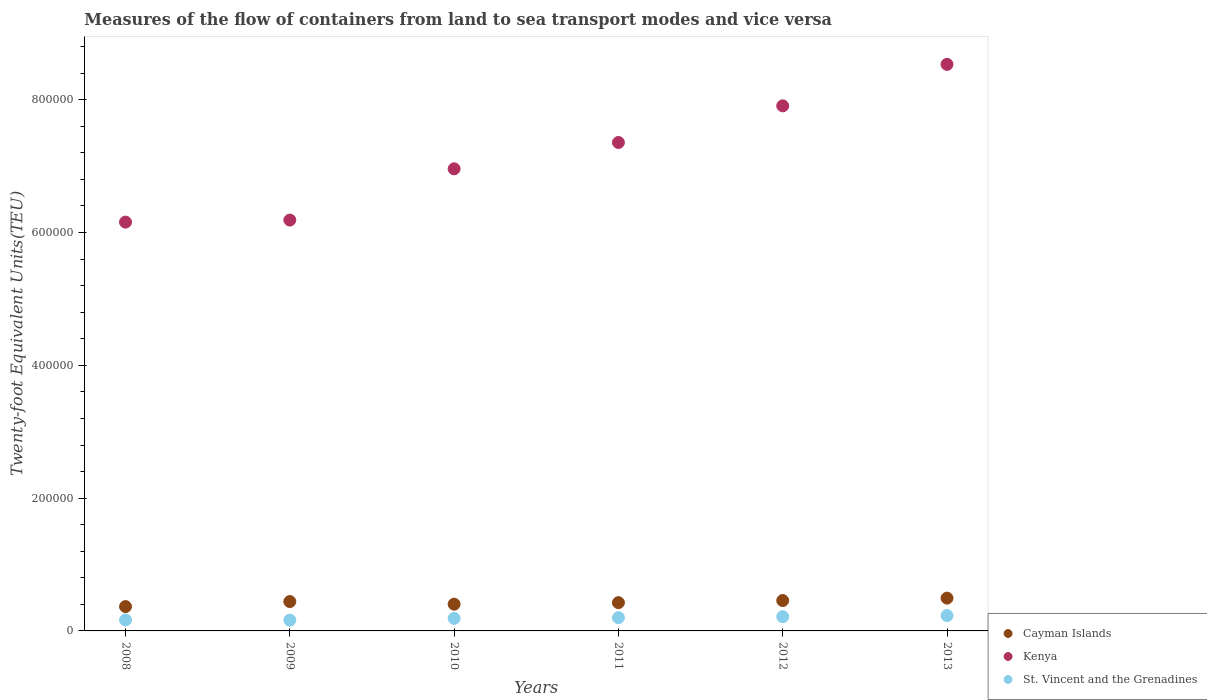What is the container port traffic in St. Vincent and the Grenadines in 2008?
Your answer should be very brief. 1.66e+04. Across all years, what is the maximum container port traffic in Kenya?
Offer a very short reply. 8.53e+05. Across all years, what is the minimum container port traffic in Kenya?
Ensure brevity in your answer.  6.16e+05. In which year was the container port traffic in Kenya maximum?
Your response must be concise. 2013. What is the total container port traffic in Cayman Islands in the graph?
Offer a very short reply. 2.59e+05. What is the difference between the container port traffic in St. Vincent and the Grenadines in 2009 and that in 2012?
Provide a succinct answer. -5183.42. What is the difference between the container port traffic in St. Vincent and the Grenadines in 2009 and the container port traffic in Cayman Islands in 2012?
Your answer should be compact. -2.95e+04. What is the average container port traffic in Cayman Islands per year?
Offer a terse response. 4.31e+04. In the year 2009, what is the difference between the container port traffic in St. Vincent and the Grenadines and container port traffic in Kenya?
Your response must be concise. -6.03e+05. What is the ratio of the container port traffic in St. Vincent and the Grenadines in 2010 to that in 2012?
Your answer should be very brief. 0.88. Is the container port traffic in St. Vincent and the Grenadines in 2009 less than that in 2013?
Your answer should be very brief. Yes. Is the difference between the container port traffic in St. Vincent and the Grenadines in 2009 and 2011 greater than the difference between the container port traffic in Kenya in 2009 and 2011?
Offer a very short reply. Yes. What is the difference between the highest and the second highest container port traffic in St. Vincent and the Grenadines?
Offer a terse response. 1692.29. What is the difference between the highest and the lowest container port traffic in Cayman Islands?
Your answer should be very brief. 1.27e+04. In how many years, is the container port traffic in St. Vincent and the Grenadines greater than the average container port traffic in St. Vincent and the Grenadines taken over all years?
Provide a short and direct response. 3. Does the container port traffic in Kenya monotonically increase over the years?
Give a very brief answer. Yes. Is the container port traffic in Cayman Islands strictly less than the container port traffic in St. Vincent and the Grenadines over the years?
Provide a short and direct response. No. Does the graph contain any zero values?
Your response must be concise. No. Does the graph contain grids?
Offer a very short reply. No. Where does the legend appear in the graph?
Offer a terse response. Bottom right. What is the title of the graph?
Offer a very short reply. Measures of the flow of containers from land to sea transport modes and vice versa. What is the label or title of the X-axis?
Your answer should be very brief. Years. What is the label or title of the Y-axis?
Ensure brevity in your answer.  Twenty-foot Equivalent Units(TEU). What is the Twenty-foot Equivalent Units(TEU) of Cayman Islands in 2008?
Keep it short and to the point. 3.66e+04. What is the Twenty-foot Equivalent Units(TEU) in Kenya in 2008?
Keep it short and to the point. 6.16e+05. What is the Twenty-foot Equivalent Units(TEU) in St. Vincent and the Grenadines in 2008?
Keep it short and to the point. 1.66e+04. What is the Twenty-foot Equivalent Units(TEU) of Cayman Islands in 2009?
Your answer should be compact. 4.42e+04. What is the Twenty-foot Equivalent Units(TEU) of Kenya in 2009?
Keep it short and to the point. 6.19e+05. What is the Twenty-foot Equivalent Units(TEU) of St. Vincent and the Grenadines in 2009?
Your answer should be compact. 1.62e+04. What is the Twenty-foot Equivalent Units(TEU) of Cayman Islands in 2010?
Give a very brief answer. 4.03e+04. What is the Twenty-foot Equivalent Units(TEU) of Kenya in 2010?
Offer a very short reply. 6.96e+05. What is the Twenty-foot Equivalent Units(TEU) of St. Vincent and the Grenadines in 2010?
Keep it short and to the point. 1.89e+04. What is the Twenty-foot Equivalent Units(TEU) of Cayman Islands in 2011?
Ensure brevity in your answer.  4.26e+04. What is the Twenty-foot Equivalent Units(TEU) in Kenya in 2011?
Your answer should be compact. 7.36e+05. What is the Twenty-foot Equivalent Units(TEU) of St. Vincent and the Grenadines in 2011?
Give a very brief answer. 1.99e+04. What is the Twenty-foot Equivalent Units(TEU) in Cayman Islands in 2012?
Ensure brevity in your answer.  4.58e+04. What is the Twenty-foot Equivalent Units(TEU) of Kenya in 2012?
Make the answer very short. 7.91e+05. What is the Twenty-foot Equivalent Units(TEU) in St. Vincent and the Grenadines in 2012?
Make the answer very short. 2.14e+04. What is the Twenty-foot Equivalent Units(TEU) of Cayman Islands in 2013?
Your answer should be very brief. 4.94e+04. What is the Twenty-foot Equivalent Units(TEU) of Kenya in 2013?
Your response must be concise. 8.53e+05. What is the Twenty-foot Equivalent Units(TEU) in St. Vincent and the Grenadines in 2013?
Provide a short and direct response. 2.31e+04. Across all years, what is the maximum Twenty-foot Equivalent Units(TEU) of Cayman Islands?
Your response must be concise. 4.94e+04. Across all years, what is the maximum Twenty-foot Equivalent Units(TEU) of Kenya?
Provide a succinct answer. 8.53e+05. Across all years, what is the maximum Twenty-foot Equivalent Units(TEU) of St. Vincent and the Grenadines?
Give a very brief answer. 2.31e+04. Across all years, what is the minimum Twenty-foot Equivalent Units(TEU) of Cayman Islands?
Make the answer very short. 3.66e+04. Across all years, what is the minimum Twenty-foot Equivalent Units(TEU) in Kenya?
Your answer should be compact. 6.16e+05. Across all years, what is the minimum Twenty-foot Equivalent Units(TEU) of St. Vincent and the Grenadines?
Give a very brief answer. 1.62e+04. What is the total Twenty-foot Equivalent Units(TEU) of Cayman Islands in the graph?
Your answer should be very brief. 2.59e+05. What is the total Twenty-foot Equivalent Units(TEU) in Kenya in the graph?
Offer a very short reply. 4.31e+06. What is the total Twenty-foot Equivalent Units(TEU) in St. Vincent and the Grenadines in the graph?
Ensure brevity in your answer.  1.16e+05. What is the difference between the Twenty-foot Equivalent Units(TEU) of Cayman Islands in 2008 and that in 2009?
Make the answer very short. -7571. What is the difference between the Twenty-foot Equivalent Units(TEU) of Kenya in 2008 and that in 2009?
Make the answer very short. -3083. What is the difference between the Twenty-foot Equivalent Units(TEU) in St. Vincent and the Grenadines in 2008 and that in 2009?
Your answer should be very brief. 332. What is the difference between the Twenty-foot Equivalent Units(TEU) in Cayman Islands in 2008 and that in 2010?
Make the answer very short. -3637. What is the difference between the Twenty-foot Equivalent Units(TEU) of Kenya in 2008 and that in 2010?
Provide a succinct answer. -8.03e+04. What is the difference between the Twenty-foot Equivalent Units(TEU) of St. Vincent and the Grenadines in 2008 and that in 2010?
Keep it short and to the point. -2282.32. What is the difference between the Twenty-foot Equivalent Units(TEU) of Cayman Islands in 2008 and that in 2011?
Keep it short and to the point. -5933. What is the difference between the Twenty-foot Equivalent Units(TEU) in Kenya in 2008 and that in 2011?
Make the answer very short. -1.20e+05. What is the difference between the Twenty-foot Equivalent Units(TEU) in St. Vincent and the Grenadines in 2008 and that in 2011?
Keep it short and to the point. -3356.9. What is the difference between the Twenty-foot Equivalent Units(TEU) of Cayman Islands in 2008 and that in 2012?
Keep it short and to the point. -9126.27. What is the difference between the Twenty-foot Equivalent Units(TEU) of Kenya in 2008 and that in 2012?
Make the answer very short. -1.75e+05. What is the difference between the Twenty-foot Equivalent Units(TEU) of St. Vincent and the Grenadines in 2008 and that in 2012?
Provide a short and direct response. -4851.42. What is the difference between the Twenty-foot Equivalent Units(TEU) in Cayman Islands in 2008 and that in 2013?
Give a very brief answer. -1.27e+04. What is the difference between the Twenty-foot Equivalent Units(TEU) of Kenya in 2008 and that in 2013?
Offer a terse response. -2.38e+05. What is the difference between the Twenty-foot Equivalent Units(TEU) in St. Vincent and the Grenadines in 2008 and that in 2013?
Provide a succinct answer. -6543.71. What is the difference between the Twenty-foot Equivalent Units(TEU) in Cayman Islands in 2009 and that in 2010?
Give a very brief answer. 3934. What is the difference between the Twenty-foot Equivalent Units(TEU) of Kenya in 2009 and that in 2010?
Keep it short and to the point. -7.72e+04. What is the difference between the Twenty-foot Equivalent Units(TEU) in St. Vincent and the Grenadines in 2009 and that in 2010?
Make the answer very short. -2614.32. What is the difference between the Twenty-foot Equivalent Units(TEU) of Cayman Islands in 2009 and that in 2011?
Ensure brevity in your answer.  1638. What is the difference between the Twenty-foot Equivalent Units(TEU) of Kenya in 2009 and that in 2011?
Offer a terse response. -1.17e+05. What is the difference between the Twenty-foot Equivalent Units(TEU) of St. Vincent and the Grenadines in 2009 and that in 2011?
Provide a short and direct response. -3688.9. What is the difference between the Twenty-foot Equivalent Units(TEU) in Cayman Islands in 2009 and that in 2012?
Provide a short and direct response. -1555.28. What is the difference between the Twenty-foot Equivalent Units(TEU) of Kenya in 2009 and that in 2012?
Give a very brief answer. -1.72e+05. What is the difference between the Twenty-foot Equivalent Units(TEU) in St. Vincent and the Grenadines in 2009 and that in 2012?
Make the answer very short. -5183.42. What is the difference between the Twenty-foot Equivalent Units(TEU) in Cayman Islands in 2009 and that in 2013?
Make the answer very short. -5171.13. What is the difference between the Twenty-foot Equivalent Units(TEU) of Kenya in 2009 and that in 2013?
Ensure brevity in your answer.  -2.35e+05. What is the difference between the Twenty-foot Equivalent Units(TEU) of St. Vincent and the Grenadines in 2009 and that in 2013?
Offer a very short reply. -6875.71. What is the difference between the Twenty-foot Equivalent Units(TEU) in Cayman Islands in 2010 and that in 2011?
Your answer should be compact. -2296. What is the difference between the Twenty-foot Equivalent Units(TEU) in Kenya in 2010 and that in 2011?
Your response must be concise. -3.97e+04. What is the difference between the Twenty-foot Equivalent Units(TEU) of St. Vincent and the Grenadines in 2010 and that in 2011?
Your response must be concise. -1074.58. What is the difference between the Twenty-foot Equivalent Units(TEU) of Cayman Islands in 2010 and that in 2012?
Provide a succinct answer. -5489.27. What is the difference between the Twenty-foot Equivalent Units(TEU) in Kenya in 2010 and that in 2012?
Your answer should be very brief. -9.48e+04. What is the difference between the Twenty-foot Equivalent Units(TEU) in St. Vincent and the Grenadines in 2010 and that in 2012?
Ensure brevity in your answer.  -2569.1. What is the difference between the Twenty-foot Equivalent Units(TEU) of Cayman Islands in 2010 and that in 2013?
Your answer should be very brief. -9105.13. What is the difference between the Twenty-foot Equivalent Units(TEU) in Kenya in 2010 and that in 2013?
Provide a succinct answer. -1.57e+05. What is the difference between the Twenty-foot Equivalent Units(TEU) of St. Vincent and the Grenadines in 2010 and that in 2013?
Offer a terse response. -4261.39. What is the difference between the Twenty-foot Equivalent Units(TEU) in Cayman Islands in 2011 and that in 2012?
Keep it short and to the point. -3193.28. What is the difference between the Twenty-foot Equivalent Units(TEU) in Kenya in 2011 and that in 2012?
Keep it short and to the point. -5.52e+04. What is the difference between the Twenty-foot Equivalent Units(TEU) in St. Vincent and the Grenadines in 2011 and that in 2012?
Your answer should be compact. -1494.52. What is the difference between the Twenty-foot Equivalent Units(TEU) in Cayman Islands in 2011 and that in 2013?
Provide a short and direct response. -6809.13. What is the difference between the Twenty-foot Equivalent Units(TEU) of Kenya in 2011 and that in 2013?
Keep it short and to the point. -1.18e+05. What is the difference between the Twenty-foot Equivalent Units(TEU) of St. Vincent and the Grenadines in 2011 and that in 2013?
Make the answer very short. -3186.81. What is the difference between the Twenty-foot Equivalent Units(TEU) of Cayman Islands in 2012 and that in 2013?
Your response must be concise. -3615.85. What is the difference between the Twenty-foot Equivalent Units(TEU) of Kenya in 2012 and that in 2013?
Keep it short and to the point. -6.25e+04. What is the difference between the Twenty-foot Equivalent Units(TEU) in St. Vincent and the Grenadines in 2012 and that in 2013?
Your answer should be compact. -1692.29. What is the difference between the Twenty-foot Equivalent Units(TEU) in Cayman Islands in 2008 and the Twenty-foot Equivalent Units(TEU) in Kenya in 2009?
Offer a terse response. -5.82e+05. What is the difference between the Twenty-foot Equivalent Units(TEU) in Cayman Islands in 2008 and the Twenty-foot Equivalent Units(TEU) in St. Vincent and the Grenadines in 2009?
Keep it short and to the point. 2.04e+04. What is the difference between the Twenty-foot Equivalent Units(TEU) in Kenya in 2008 and the Twenty-foot Equivalent Units(TEU) in St. Vincent and the Grenadines in 2009?
Your response must be concise. 5.99e+05. What is the difference between the Twenty-foot Equivalent Units(TEU) of Cayman Islands in 2008 and the Twenty-foot Equivalent Units(TEU) of Kenya in 2010?
Your answer should be compact. -6.59e+05. What is the difference between the Twenty-foot Equivalent Units(TEU) of Cayman Islands in 2008 and the Twenty-foot Equivalent Units(TEU) of St. Vincent and the Grenadines in 2010?
Your answer should be compact. 1.78e+04. What is the difference between the Twenty-foot Equivalent Units(TEU) of Kenya in 2008 and the Twenty-foot Equivalent Units(TEU) of St. Vincent and the Grenadines in 2010?
Offer a terse response. 5.97e+05. What is the difference between the Twenty-foot Equivalent Units(TEU) of Cayman Islands in 2008 and the Twenty-foot Equivalent Units(TEU) of Kenya in 2011?
Provide a succinct answer. -6.99e+05. What is the difference between the Twenty-foot Equivalent Units(TEU) of Cayman Islands in 2008 and the Twenty-foot Equivalent Units(TEU) of St. Vincent and the Grenadines in 2011?
Make the answer very short. 1.67e+04. What is the difference between the Twenty-foot Equivalent Units(TEU) of Kenya in 2008 and the Twenty-foot Equivalent Units(TEU) of St. Vincent and the Grenadines in 2011?
Your answer should be compact. 5.96e+05. What is the difference between the Twenty-foot Equivalent Units(TEU) of Cayman Islands in 2008 and the Twenty-foot Equivalent Units(TEU) of Kenya in 2012?
Keep it short and to the point. -7.54e+05. What is the difference between the Twenty-foot Equivalent Units(TEU) in Cayman Islands in 2008 and the Twenty-foot Equivalent Units(TEU) in St. Vincent and the Grenadines in 2012?
Provide a short and direct response. 1.52e+04. What is the difference between the Twenty-foot Equivalent Units(TEU) of Kenya in 2008 and the Twenty-foot Equivalent Units(TEU) of St. Vincent and the Grenadines in 2012?
Give a very brief answer. 5.94e+05. What is the difference between the Twenty-foot Equivalent Units(TEU) of Cayman Islands in 2008 and the Twenty-foot Equivalent Units(TEU) of Kenya in 2013?
Offer a very short reply. -8.17e+05. What is the difference between the Twenty-foot Equivalent Units(TEU) in Cayman Islands in 2008 and the Twenty-foot Equivalent Units(TEU) in St. Vincent and the Grenadines in 2013?
Make the answer very short. 1.35e+04. What is the difference between the Twenty-foot Equivalent Units(TEU) in Kenya in 2008 and the Twenty-foot Equivalent Units(TEU) in St. Vincent and the Grenadines in 2013?
Provide a succinct answer. 5.93e+05. What is the difference between the Twenty-foot Equivalent Units(TEU) of Cayman Islands in 2009 and the Twenty-foot Equivalent Units(TEU) of Kenya in 2010?
Your response must be concise. -6.52e+05. What is the difference between the Twenty-foot Equivalent Units(TEU) in Cayman Islands in 2009 and the Twenty-foot Equivalent Units(TEU) in St. Vincent and the Grenadines in 2010?
Provide a short and direct response. 2.54e+04. What is the difference between the Twenty-foot Equivalent Units(TEU) in Kenya in 2009 and the Twenty-foot Equivalent Units(TEU) in St. Vincent and the Grenadines in 2010?
Offer a terse response. 6.00e+05. What is the difference between the Twenty-foot Equivalent Units(TEU) of Cayman Islands in 2009 and the Twenty-foot Equivalent Units(TEU) of Kenya in 2011?
Your answer should be compact. -6.91e+05. What is the difference between the Twenty-foot Equivalent Units(TEU) of Cayman Islands in 2009 and the Twenty-foot Equivalent Units(TEU) of St. Vincent and the Grenadines in 2011?
Offer a terse response. 2.43e+04. What is the difference between the Twenty-foot Equivalent Units(TEU) of Kenya in 2009 and the Twenty-foot Equivalent Units(TEU) of St. Vincent and the Grenadines in 2011?
Keep it short and to the point. 5.99e+05. What is the difference between the Twenty-foot Equivalent Units(TEU) in Cayman Islands in 2009 and the Twenty-foot Equivalent Units(TEU) in Kenya in 2012?
Ensure brevity in your answer.  -7.47e+05. What is the difference between the Twenty-foot Equivalent Units(TEU) of Cayman Islands in 2009 and the Twenty-foot Equivalent Units(TEU) of St. Vincent and the Grenadines in 2012?
Provide a succinct answer. 2.28e+04. What is the difference between the Twenty-foot Equivalent Units(TEU) of Kenya in 2009 and the Twenty-foot Equivalent Units(TEU) of St. Vincent and the Grenadines in 2012?
Provide a short and direct response. 5.97e+05. What is the difference between the Twenty-foot Equivalent Units(TEU) of Cayman Islands in 2009 and the Twenty-foot Equivalent Units(TEU) of Kenya in 2013?
Provide a short and direct response. -8.09e+05. What is the difference between the Twenty-foot Equivalent Units(TEU) in Cayman Islands in 2009 and the Twenty-foot Equivalent Units(TEU) in St. Vincent and the Grenadines in 2013?
Your answer should be compact. 2.11e+04. What is the difference between the Twenty-foot Equivalent Units(TEU) in Kenya in 2009 and the Twenty-foot Equivalent Units(TEU) in St. Vincent and the Grenadines in 2013?
Your answer should be very brief. 5.96e+05. What is the difference between the Twenty-foot Equivalent Units(TEU) of Cayman Islands in 2010 and the Twenty-foot Equivalent Units(TEU) of Kenya in 2011?
Make the answer very short. -6.95e+05. What is the difference between the Twenty-foot Equivalent Units(TEU) of Cayman Islands in 2010 and the Twenty-foot Equivalent Units(TEU) of St. Vincent and the Grenadines in 2011?
Make the answer very short. 2.04e+04. What is the difference between the Twenty-foot Equivalent Units(TEU) in Kenya in 2010 and the Twenty-foot Equivalent Units(TEU) in St. Vincent and the Grenadines in 2011?
Keep it short and to the point. 6.76e+05. What is the difference between the Twenty-foot Equivalent Units(TEU) in Cayman Islands in 2010 and the Twenty-foot Equivalent Units(TEU) in Kenya in 2012?
Your answer should be very brief. -7.51e+05. What is the difference between the Twenty-foot Equivalent Units(TEU) in Cayman Islands in 2010 and the Twenty-foot Equivalent Units(TEU) in St. Vincent and the Grenadines in 2012?
Your answer should be compact. 1.89e+04. What is the difference between the Twenty-foot Equivalent Units(TEU) in Kenya in 2010 and the Twenty-foot Equivalent Units(TEU) in St. Vincent and the Grenadines in 2012?
Provide a short and direct response. 6.75e+05. What is the difference between the Twenty-foot Equivalent Units(TEU) in Cayman Islands in 2010 and the Twenty-foot Equivalent Units(TEU) in Kenya in 2013?
Provide a short and direct response. -8.13e+05. What is the difference between the Twenty-foot Equivalent Units(TEU) in Cayman Islands in 2010 and the Twenty-foot Equivalent Units(TEU) in St. Vincent and the Grenadines in 2013?
Offer a terse response. 1.72e+04. What is the difference between the Twenty-foot Equivalent Units(TEU) in Kenya in 2010 and the Twenty-foot Equivalent Units(TEU) in St. Vincent and the Grenadines in 2013?
Provide a succinct answer. 6.73e+05. What is the difference between the Twenty-foot Equivalent Units(TEU) of Cayman Islands in 2011 and the Twenty-foot Equivalent Units(TEU) of Kenya in 2012?
Make the answer very short. -7.48e+05. What is the difference between the Twenty-foot Equivalent Units(TEU) in Cayman Islands in 2011 and the Twenty-foot Equivalent Units(TEU) in St. Vincent and the Grenadines in 2012?
Provide a short and direct response. 2.12e+04. What is the difference between the Twenty-foot Equivalent Units(TEU) in Kenya in 2011 and the Twenty-foot Equivalent Units(TEU) in St. Vincent and the Grenadines in 2012?
Your answer should be compact. 7.14e+05. What is the difference between the Twenty-foot Equivalent Units(TEU) of Cayman Islands in 2011 and the Twenty-foot Equivalent Units(TEU) of Kenya in 2013?
Offer a very short reply. -8.11e+05. What is the difference between the Twenty-foot Equivalent Units(TEU) of Cayman Islands in 2011 and the Twenty-foot Equivalent Units(TEU) of St. Vincent and the Grenadines in 2013?
Ensure brevity in your answer.  1.95e+04. What is the difference between the Twenty-foot Equivalent Units(TEU) in Kenya in 2011 and the Twenty-foot Equivalent Units(TEU) in St. Vincent and the Grenadines in 2013?
Offer a terse response. 7.13e+05. What is the difference between the Twenty-foot Equivalent Units(TEU) of Cayman Islands in 2012 and the Twenty-foot Equivalent Units(TEU) of Kenya in 2013?
Provide a short and direct response. -8.08e+05. What is the difference between the Twenty-foot Equivalent Units(TEU) in Cayman Islands in 2012 and the Twenty-foot Equivalent Units(TEU) in St. Vincent and the Grenadines in 2013?
Keep it short and to the point. 2.27e+04. What is the difference between the Twenty-foot Equivalent Units(TEU) of Kenya in 2012 and the Twenty-foot Equivalent Units(TEU) of St. Vincent and the Grenadines in 2013?
Your response must be concise. 7.68e+05. What is the average Twenty-foot Equivalent Units(TEU) of Cayman Islands per year?
Offer a very short reply. 4.31e+04. What is the average Twenty-foot Equivalent Units(TEU) in Kenya per year?
Make the answer very short. 7.18e+05. What is the average Twenty-foot Equivalent Units(TEU) in St. Vincent and the Grenadines per year?
Your response must be concise. 1.94e+04. In the year 2008, what is the difference between the Twenty-foot Equivalent Units(TEU) of Cayman Islands and Twenty-foot Equivalent Units(TEU) of Kenya?
Offer a very short reply. -5.79e+05. In the year 2008, what is the difference between the Twenty-foot Equivalent Units(TEU) of Cayman Islands and Twenty-foot Equivalent Units(TEU) of St. Vincent and the Grenadines?
Give a very brief answer. 2.01e+04. In the year 2008, what is the difference between the Twenty-foot Equivalent Units(TEU) in Kenya and Twenty-foot Equivalent Units(TEU) in St. Vincent and the Grenadines?
Make the answer very short. 5.99e+05. In the year 2009, what is the difference between the Twenty-foot Equivalent Units(TEU) of Cayman Islands and Twenty-foot Equivalent Units(TEU) of Kenya?
Provide a succinct answer. -5.75e+05. In the year 2009, what is the difference between the Twenty-foot Equivalent Units(TEU) of Cayman Islands and Twenty-foot Equivalent Units(TEU) of St. Vincent and the Grenadines?
Offer a very short reply. 2.80e+04. In the year 2009, what is the difference between the Twenty-foot Equivalent Units(TEU) of Kenya and Twenty-foot Equivalent Units(TEU) of St. Vincent and the Grenadines?
Ensure brevity in your answer.  6.03e+05. In the year 2010, what is the difference between the Twenty-foot Equivalent Units(TEU) in Cayman Islands and Twenty-foot Equivalent Units(TEU) in Kenya?
Your answer should be compact. -6.56e+05. In the year 2010, what is the difference between the Twenty-foot Equivalent Units(TEU) in Cayman Islands and Twenty-foot Equivalent Units(TEU) in St. Vincent and the Grenadines?
Your answer should be very brief. 2.14e+04. In the year 2010, what is the difference between the Twenty-foot Equivalent Units(TEU) in Kenya and Twenty-foot Equivalent Units(TEU) in St. Vincent and the Grenadines?
Give a very brief answer. 6.77e+05. In the year 2011, what is the difference between the Twenty-foot Equivalent Units(TEU) of Cayman Islands and Twenty-foot Equivalent Units(TEU) of Kenya?
Your answer should be compact. -6.93e+05. In the year 2011, what is the difference between the Twenty-foot Equivalent Units(TEU) of Cayman Islands and Twenty-foot Equivalent Units(TEU) of St. Vincent and the Grenadines?
Your answer should be compact. 2.27e+04. In the year 2011, what is the difference between the Twenty-foot Equivalent Units(TEU) of Kenya and Twenty-foot Equivalent Units(TEU) of St. Vincent and the Grenadines?
Give a very brief answer. 7.16e+05. In the year 2012, what is the difference between the Twenty-foot Equivalent Units(TEU) of Cayman Islands and Twenty-foot Equivalent Units(TEU) of Kenya?
Make the answer very short. -7.45e+05. In the year 2012, what is the difference between the Twenty-foot Equivalent Units(TEU) in Cayman Islands and Twenty-foot Equivalent Units(TEU) in St. Vincent and the Grenadines?
Provide a short and direct response. 2.43e+04. In the year 2012, what is the difference between the Twenty-foot Equivalent Units(TEU) of Kenya and Twenty-foot Equivalent Units(TEU) of St. Vincent and the Grenadines?
Ensure brevity in your answer.  7.69e+05. In the year 2013, what is the difference between the Twenty-foot Equivalent Units(TEU) in Cayman Islands and Twenty-foot Equivalent Units(TEU) in Kenya?
Your response must be concise. -8.04e+05. In the year 2013, what is the difference between the Twenty-foot Equivalent Units(TEU) of Cayman Islands and Twenty-foot Equivalent Units(TEU) of St. Vincent and the Grenadines?
Ensure brevity in your answer.  2.63e+04. In the year 2013, what is the difference between the Twenty-foot Equivalent Units(TEU) in Kenya and Twenty-foot Equivalent Units(TEU) in St. Vincent and the Grenadines?
Keep it short and to the point. 8.30e+05. What is the ratio of the Twenty-foot Equivalent Units(TEU) in Cayman Islands in 2008 to that in 2009?
Your response must be concise. 0.83. What is the ratio of the Twenty-foot Equivalent Units(TEU) of Kenya in 2008 to that in 2009?
Offer a terse response. 0.99. What is the ratio of the Twenty-foot Equivalent Units(TEU) of St. Vincent and the Grenadines in 2008 to that in 2009?
Your response must be concise. 1.02. What is the ratio of the Twenty-foot Equivalent Units(TEU) in Cayman Islands in 2008 to that in 2010?
Keep it short and to the point. 0.91. What is the ratio of the Twenty-foot Equivalent Units(TEU) of Kenya in 2008 to that in 2010?
Ensure brevity in your answer.  0.88. What is the ratio of the Twenty-foot Equivalent Units(TEU) in St. Vincent and the Grenadines in 2008 to that in 2010?
Provide a succinct answer. 0.88. What is the ratio of the Twenty-foot Equivalent Units(TEU) of Cayman Islands in 2008 to that in 2011?
Your response must be concise. 0.86. What is the ratio of the Twenty-foot Equivalent Units(TEU) in Kenya in 2008 to that in 2011?
Provide a short and direct response. 0.84. What is the ratio of the Twenty-foot Equivalent Units(TEU) in St. Vincent and the Grenadines in 2008 to that in 2011?
Your answer should be very brief. 0.83. What is the ratio of the Twenty-foot Equivalent Units(TEU) in Cayman Islands in 2008 to that in 2012?
Your answer should be compact. 0.8. What is the ratio of the Twenty-foot Equivalent Units(TEU) in Kenya in 2008 to that in 2012?
Offer a terse response. 0.78. What is the ratio of the Twenty-foot Equivalent Units(TEU) of St. Vincent and the Grenadines in 2008 to that in 2012?
Provide a short and direct response. 0.77. What is the ratio of the Twenty-foot Equivalent Units(TEU) of Cayman Islands in 2008 to that in 2013?
Keep it short and to the point. 0.74. What is the ratio of the Twenty-foot Equivalent Units(TEU) in Kenya in 2008 to that in 2013?
Ensure brevity in your answer.  0.72. What is the ratio of the Twenty-foot Equivalent Units(TEU) in St. Vincent and the Grenadines in 2008 to that in 2013?
Your answer should be compact. 0.72. What is the ratio of the Twenty-foot Equivalent Units(TEU) in Cayman Islands in 2009 to that in 2010?
Provide a succinct answer. 1.1. What is the ratio of the Twenty-foot Equivalent Units(TEU) of Kenya in 2009 to that in 2010?
Keep it short and to the point. 0.89. What is the ratio of the Twenty-foot Equivalent Units(TEU) in St. Vincent and the Grenadines in 2009 to that in 2010?
Offer a terse response. 0.86. What is the ratio of the Twenty-foot Equivalent Units(TEU) in Kenya in 2009 to that in 2011?
Your response must be concise. 0.84. What is the ratio of the Twenty-foot Equivalent Units(TEU) in St. Vincent and the Grenadines in 2009 to that in 2011?
Ensure brevity in your answer.  0.81. What is the ratio of the Twenty-foot Equivalent Units(TEU) of Kenya in 2009 to that in 2012?
Provide a short and direct response. 0.78. What is the ratio of the Twenty-foot Equivalent Units(TEU) in St. Vincent and the Grenadines in 2009 to that in 2012?
Provide a short and direct response. 0.76. What is the ratio of the Twenty-foot Equivalent Units(TEU) of Cayman Islands in 2009 to that in 2013?
Provide a short and direct response. 0.9. What is the ratio of the Twenty-foot Equivalent Units(TEU) in Kenya in 2009 to that in 2013?
Make the answer very short. 0.73. What is the ratio of the Twenty-foot Equivalent Units(TEU) in St. Vincent and the Grenadines in 2009 to that in 2013?
Your response must be concise. 0.7. What is the ratio of the Twenty-foot Equivalent Units(TEU) in Cayman Islands in 2010 to that in 2011?
Ensure brevity in your answer.  0.95. What is the ratio of the Twenty-foot Equivalent Units(TEU) in Kenya in 2010 to that in 2011?
Give a very brief answer. 0.95. What is the ratio of the Twenty-foot Equivalent Units(TEU) of St. Vincent and the Grenadines in 2010 to that in 2011?
Your answer should be compact. 0.95. What is the ratio of the Twenty-foot Equivalent Units(TEU) of Cayman Islands in 2010 to that in 2012?
Give a very brief answer. 0.88. What is the ratio of the Twenty-foot Equivalent Units(TEU) of Kenya in 2010 to that in 2012?
Your answer should be very brief. 0.88. What is the ratio of the Twenty-foot Equivalent Units(TEU) of St. Vincent and the Grenadines in 2010 to that in 2012?
Your answer should be very brief. 0.88. What is the ratio of the Twenty-foot Equivalent Units(TEU) in Cayman Islands in 2010 to that in 2013?
Your answer should be very brief. 0.82. What is the ratio of the Twenty-foot Equivalent Units(TEU) in Kenya in 2010 to that in 2013?
Make the answer very short. 0.82. What is the ratio of the Twenty-foot Equivalent Units(TEU) of St. Vincent and the Grenadines in 2010 to that in 2013?
Keep it short and to the point. 0.82. What is the ratio of the Twenty-foot Equivalent Units(TEU) in Cayman Islands in 2011 to that in 2012?
Your answer should be very brief. 0.93. What is the ratio of the Twenty-foot Equivalent Units(TEU) of Kenya in 2011 to that in 2012?
Your answer should be compact. 0.93. What is the ratio of the Twenty-foot Equivalent Units(TEU) in St. Vincent and the Grenadines in 2011 to that in 2012?
Give a very brief answer. 0.93. What is the ratio of the Twenty-foot Equivalent Units(TEU) in Cayman Islands in 2011 to that in 2013?
Your response must be concise. 0.86. What is the ratio of the Twenty-foot Equivalent Units(TEU) of Kenya in 2011 to that in 2013?
Your answer should be very brief. 0.86. What is the ratio of the Twenty-foot Equivalent Units(TEU) in St. Vincent and the Grenadines in 2011 to that in 2013?
Make the answer very short. 0.86. What is the ratio of the Twenty-foot Equivalent Units(TEU) in Cayman Islands in 2012 to that in 2013?
Your answer should be very brief. 0.93. What is the ratio of the Twenty-foot Equivalent Units(TEU) of Kenya in 2012 to that in 2013?
Offer a very short reply. 0.93. What is the ratio of the Twenty-foot Equivalent Units(TEU) of St. Vincent and the Grenadines in 2012 to that in 2013?
Your response must be concise. 0.93. What is the difference between the highest and the second highest Twenty-foot Equivalent Units(TEU) of Cayman Islands?
Provide a succinct answer. 3615.85. What is the difference between the highest and the second highest Twenty-foot Equivalent Units(TEU) in Kenya?
Your answer should be very brief. 6.25e+04. What is the difference between the highest and the second highest Twenty-foot Equivalent Units(TEU) in St. Vincent and the Grenadines?
Your answer should be very brief. 1692.29. What is the difference between the highest and the lowest Twenty-foot Equivalent Units(TEU) in Cayman Islands?
Offer a very short reply. 1.27e+04. What is the difference between the highest and the lowest Twenty-foot Equivalent Units(TEU) of Kenya?
Offer a very short reply. 2.38e+05. What is the difference between the highest and the lowest Twenty-foot Equivalent Units(TEU) of St. Vincent and the Grenadines?
Your response must be concise. 6875.71. 